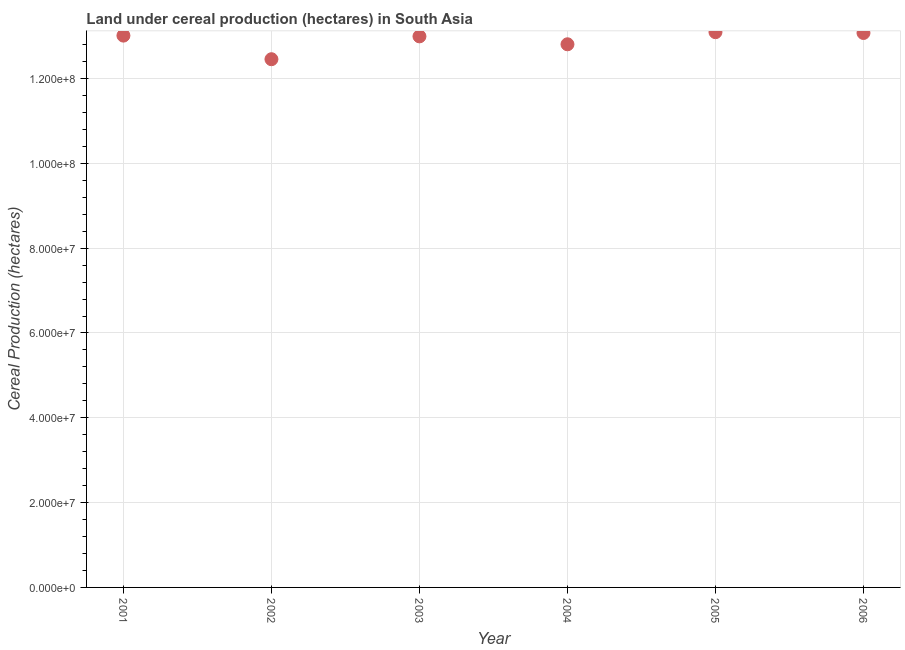What is the land under cereal production in 2004?
Offer a very short reply. 1.28e+08. Across all years, what is the maximum land under cereal production?
Your answer should be very brief. 1.31e+08. Across all years, what is the minimum land under cereal production?
Keep it short and to the point. 1.25e+08. In which year was the land under cereal production minimum?
Make the answer very short. 2002. What is the sum of the land under cereal production?
Give a very brief answer. 7.74e+08. What is the difference between the land under cereal production in 2004 and 2005?
Offer a terse response. -2.86e+06. What is the average land under cereal production per year?
Ensure brevity in your answer.  1.29e+08. What is the median land under cereal production?
Ensure brevity in your answer.  1.30e+08. What is the ratio of the land under cereal production in 2001 to that in 2002?
Your answer should be compact. 1.04. Is the land under cereal production in 2003 less than that in 2005?
Offer a terse response. Yes. Is the difference between the land under cereal production in 2001 and 2006 greater than the difference between any two years?
Your answer should be very brief. No. What is the difference between the highest and the second highest land under cereal production?
Keep it short and to the point. 1.92e+05. Is the sum of the land under cereal production in 2003 and 2005 greater than the maximum land under cereal production across all years?
Provide a succinct answer. Yes. What is the difference between the highest and the lowest land under cereal production?
Your response must be concise. 6.38e+06. How many years are there in the graph?
Your answer should be compact. 6. What is the difference between two consecutive major ticks on the Y-axis?
Make the answer very short. 2.00e+07. Are the values on the major ticks of Y-axis written in scientific E-notation?
Make the answer very short. Yes. Does the graph contain grids?
Make the answer very short. Yes. What is the title of the graph?
Offer a very short reply. Land under cereal production (hectares) in South Asia. What is the label or title of the X-axis?
Your answer should be very brief. Year. What is the label or title of the Y-axis?
Your response must be concise. Cereal Production (hectares). What is the Cereal Production (hectares) in 2001?
Make the answer very short. 1.30e+08. What is the Cereal Production (hectares) in 2002?
Your answer should be very brief. 1.25e+08. What is the Cereal Production (hectares) in 2003?
Your answer should be compact. 1.30e+08. What is the Cereal Production (hectares) in 2004?
Keep it short and to the point. 1.28e+08. What is the Cereal Production (hectares) in 2005?
Offer a terse response. 1.31e+08. What is the Cereal Production (hectares) in 2006?
Your answer should be very brief. 1.31e+08. What is the difference between the Cereal Production (hectares) in 2001 and 2002?
Offer a terse response. 5.57e+06. What is the difference between the Cereal Production (hectares) in 2001 and 2003?
Provide a short and direct response. 1.79e+05. What is the difference between the Cereal Production (hectares) in 2001 and 2004?
Offer a terse response. 2.05e+06. What is the difference between the Cereal Production (hectares) in 2001 and 2005?
Make the answer very short. -8.09e+05. What is the difference between the Cereal Production (hectares) in 2001 and 2006?
Ensure brevity in your answer.  -6.17e+05. What is the difference between the Cereal Production (hectares) in 2002 and 2003?
Make the answer very short. -5.39e+06. What is the difference between the Cereal Production (hectares) in 2002 and 2004?
Provide a succinct answer. -3.52e+06. What is the difference between the Cereal Production (hectares) in 2002 and 2005?
Your answer should be compact. -6.38e+06. What is the difference between the Cereal Production (hectares) in 2002 and 2006?
Keep it short and to the point. -6.18e+06. What is the difference between the Cereal Production (hectares) in 2003 and 2004?
Offer a very short reply. 1.87e+06. What is the difference between the Cereal Production (hectares) in 2003 and 2005?
Offer a terse response. -9.89e+05. What is the difference between the Cereal Production (hectares) in 2003 and 2006?
Ensure brevity in your answer.  -7.97e+05. What is the difference between the Cereal Production (hectares) in 2004 and 2005?
Make the answer very short. -2.86e+06. What is the difference between the Cereal Production (hectares) in 2004 and 2006?
Ensure brevity in your answer.  -2.66e+06. What is the difference between the Cereal Production (hectares) in 2005 and 2006?
Make the answer very short. 1.92e+05. What is the ratio of the Cereal Production (hectares) in 2001 to that in 2002?
Your answer should be compact. 1.04. What is the ratio of the Cereal Production (hectares) in 2001 to that in 2004?
Ensure brevity in your answer.  1.02. What is the ratio of the Cereal Production (hectares) in 2002 to that in 2005?
Provide a succinct answer. 0.95. What is the ratio of the Cereal Production (hectares) in 2002 to that in 2006?
Your answer should be very brief. 0.95. What is the ratio of the Cereal Production (hectares) in 2003 to that in 2004?
Keep it short and to the point. 1.01. What is the ratio of the Cereal Production (hectares) in 2003 to that in 2005?
Keep it short and to the point. 0.99. What is the ratio of the Cereal Production (hectares) in 2004 to that in 2005?
Provide a succinct answer. 0.98. What is the ratio of the Cereal Production (hectares) in 2004 to that in 2006?
Keep it short and to the point. 0.98. 